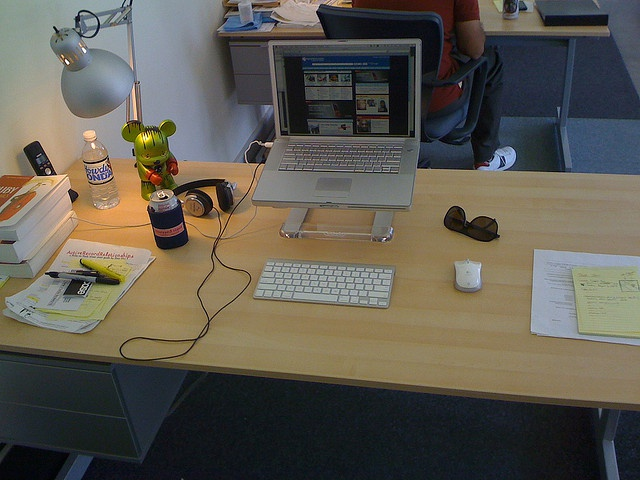Describe the objects in this image and their specific colors. I can see laptop in darkgray, gray, and black tones, chair in darkgray, black, navy, maroon, and darkblue tones, people in darkgray, black, and maroon tones, keyboard in darkgray and gray tones, and keyboard in darkgray, gray, black, and purple tones in this image. 